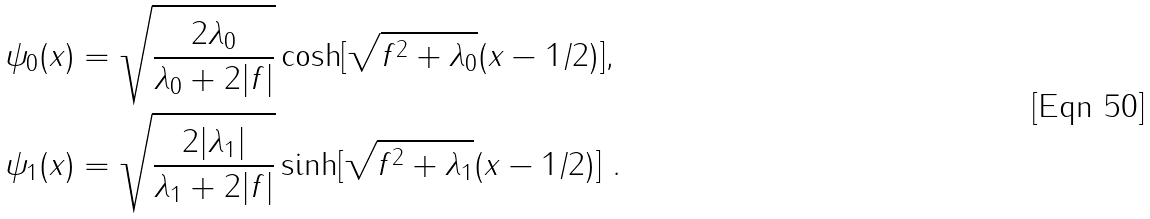<formula> <loc_0><loc_0><loc_500><loc_500>\psi _ { 0 } ( x ) & = \sqrt { \frac { 2 \lambda _ { 0 } } { \lambda _ { 0 } + 2 | f | } } \cosh [ \sqrt { f ^ { 2 } + \lambda _ { 0 } } ( x - 1 / 2 ) ] , \\ \psi _ { 1 } ( x ) & = \sqrt { \frac { 2 | \lambda _ { 1 } | } { \lambda _ { 1 } + 2 | f | } } \sinh [ \sqrt { f ^ { 2 } + \lambda _ { 1 } } ( x - 1 / 2 ) ] \ .</formula> 